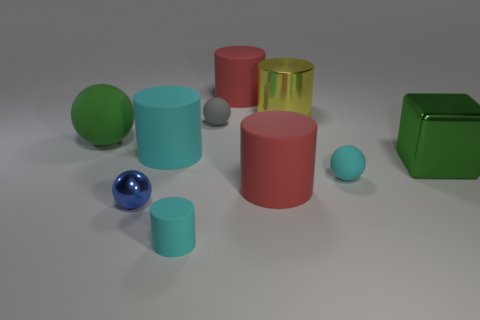There is a large green metal thing; does it have the same shape as the red object that is behind the block?
Your answer should be very brief. No. How many other objects are the same material as the small cyan cylinder?
Your answer should be compact. 6. There is a big cube; does it have the same color as the rubber ball on the left side of the big cyan rubber object?
Your answer should be compact. Yes. What is the material of the big green object right of the blue metallic thing?
Provide a succinct answer. Metal. Is there a rubber sphere that has the same color as the big metallic block?
Offer a very short reply. Yes. What is the color of the shiny block that is the same size as the metal cylinder?
Keep it short and to the point. Green. How many large objects are either yellow shiny cylinders or green shiny blocks?
Offer a very short reply. 2. Are there the same number of blue metal balls that are on the left side of the large metal cylinder and tiny blue shiny spheres that are right of the metal cube?
Your answer should be compact. No. What number of yellow shiny things are the same size as the green metal object?
Your answer should be very brief. 1. How many gray objects are either metal objects or rubber spheres?
Offer a very short reply. 1. 